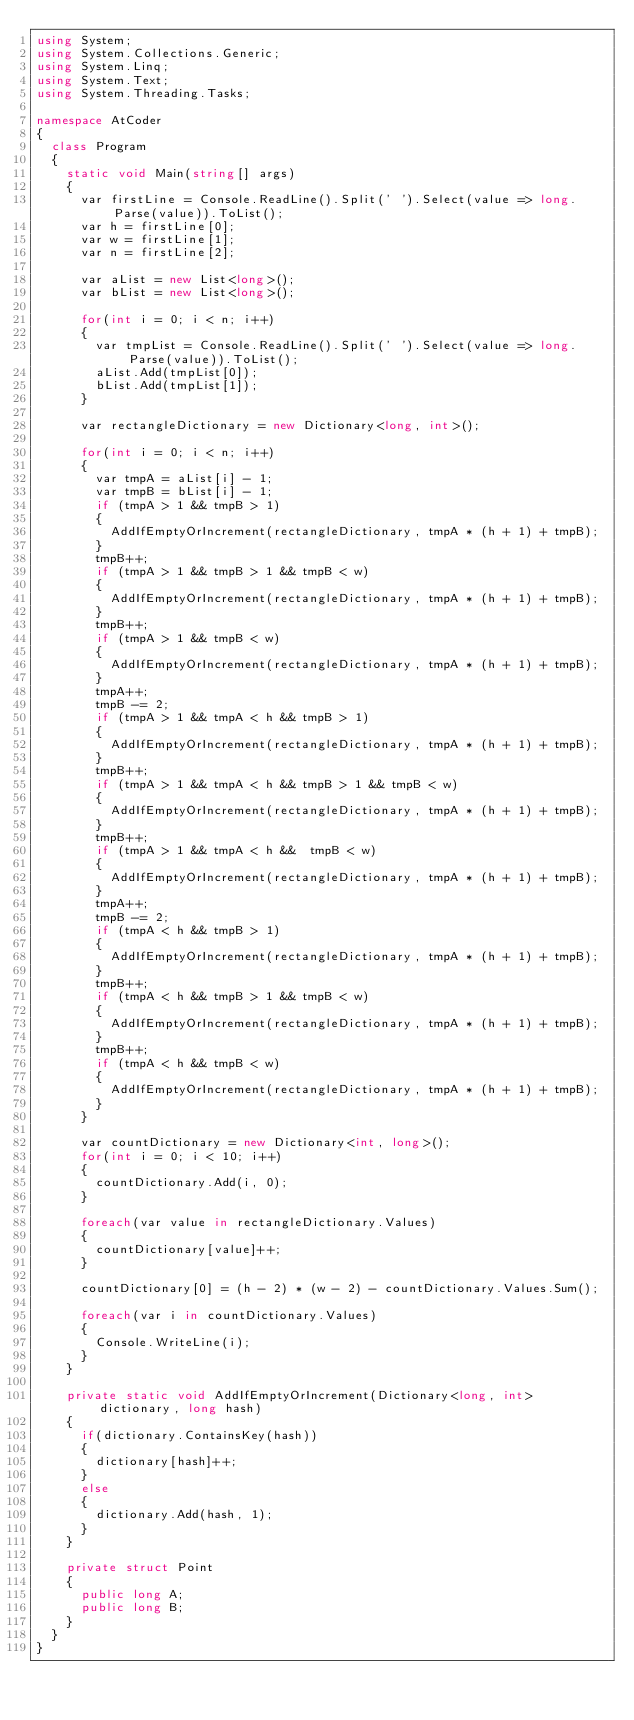<code> <loc_0><loc_0><loc_500><loc_500><_C#_>using System;
using System.Collections.Generic;
using System.Linq;
using System.Text;
using System.Threading.Tasks;

namespace AtCoder
{
	class Program
	{
		static void Main(string[] args)
		{
			var firstLine = Console.ReadLine().Split(' ').Select(value => long.Parse(value)).ToList();
			var h = firstLine[0];
			var w = firstLine[1];
			var n = firstLine[2];
			
			var aList = new List<long>();
			var bList = new List<long>();

			for(int i = 0; i < n; i++)
			{
				var tmpList = Console.ReadLine().Split(' ').Select(value => long.Parse(value)).ToList();
				aList.Add(tmpList[0]);
				bList.Add(tmpList[1]);
			}

			var rectangleDictionary = new Dictionary<long, int>();

			for(int i = 0; i < n; i++)
			{
				var tmpA = aList[i] - 1;
				var tmpB = bList[i] - 1;
				if (tmpA > 1 && tmpB > 1)
				{
					AddIfEmptyOrIncrement(rectangleDictionary, tmpA * (h + 1) + tmpB);
				}
				tmpB++;
				if (tmpA > 1 && tmpB > 1 && tmpB < w)
				{
					AddIfEmptyOrIncrement(rectangleDictionary, tmpA * (h + 1) + tmpB);
				}
				tmpB++;
				if (tmpA > 1 && tmpB < w)
				{
					AddIfEmptyOrIncrement(rectangleDictionary, tmpA * (h + 1) + tmpB);
				}
				tmpA++;
				tmpB -= 2;
				if (tmpA > 1 && tmpA < h && tmpB > 1)
				{
					AddIfEmptyOrIncrement(rectangleDictionary, tmpA * (h + 1) + tmpB);
				}
				tmpB++;
				if (tmpA > 1 && tmpA < h && tmpB > 1 && tmpB < w)
				{
					AddIfEmptyOrIncrement(rectangleDictionary, tmpA * (h + 1) + tmpB);
				}
				tmpB++;
				if (tmpA > 1 && tmpA < h &&  tmpB < w)
				{
					AddIfEmptyOrIncrement(rectangleDictionary, tmpA * (h + 1) + tmpB);
				}
				tmpA++;
				tmpB -= 2;
				if (tmpA < h && tmpB > 1)
				{
					AddIfEmptyOrIncrement(rectangleDictionary, tmpA * (h + 1) + tmpB);
				}
				tmpB++;
				if (tmpA < h && tmpB > 1 && tmpB < w)
				{
					AddIfEmptyOrIncrement(rectangleDictionary, tmpA * (h + 1) + tmpB);
				}
				tmpB++;
				if (tmpA < h && tmpB < w)
				{
					AddIfEmptyOrIncrement(rectangleDictionary, tmpA * (h + 1) + tmpB);
				}
			}

			var countDictionary = new Dictionary<int, long>();
			for(int i = 0; i < 10; i++)
			{
				countDictionary.Add(i, 0);
			}

			foreach(var value in rectangleDictionary.Values)
			{
				countDictionary[value]++;
			}

			countDictionary[0] = (h - 2) * (w - 2) - countDictionary.Values.Sum();

			foreach(var i in countDictionary.Values)
			{
				Console.WriteLine(i);
			}
		}

		private static void AddIfEmptyOrIncrement(Dictionary<long, int> dictionary, long hash)
		{
			if(dictionary.ContainsKey(hash))
			{
				dictionary[hash]++;
			}
			else
			{
				dictionary.Add(hash, 1);
			}
		}

		private struct Point
		{
			public long A;
			public long B;
		}
	}
}
</code> 